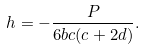Convert formula to latex. <formula><loc_0><loc_0><loc_500><loc_500>h = - \frac { P } { 6 b c ( c + 2 d ) } .</formula> 